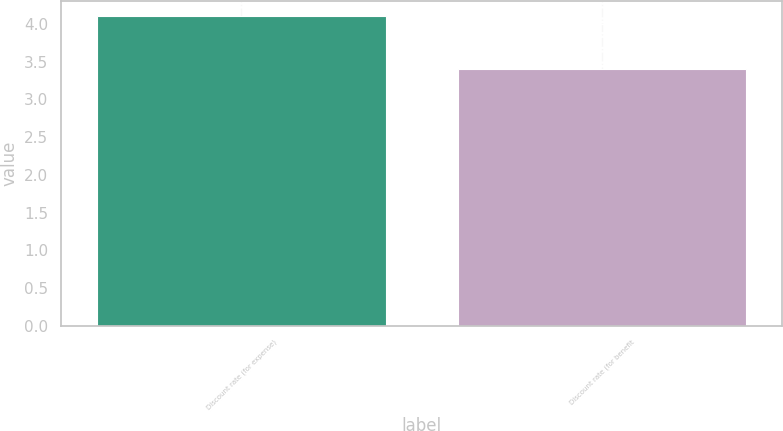Convert chart. <chart><loc_0><loc_0><loc_500><loc_500><bar_chart><fcel>Discount rate (for expense)<fcel>Discount rate (for benefit<nl><fcel>4.1<fcel>3.4<nl></chart> 